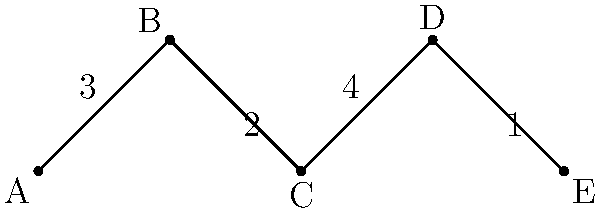At a royal banquet, five distinguished guests (A, B, C, D, and E) are to be seated at a long table. The graph represents the social connections between guests, with edge weights indicating the level of acquaintance (higher numbers mean better acquainted). What is the optimal seating arrangement to maximize social interaction, and what is the total "social score" of this arrangement? To find the optimal seating arrangement, we need to maximize the sum of edge weights between adjacent guests. Let's approach this step-by-step:

1. First, list all possible seating arrangements:
   ABCDE, ABDCE, ABEDC, ACBDE, ACDBE, ACEBD, ADCBE, ADBCE, ADEBC, AEBCD, AECBD, AEDBC

2. For each arrangement, calculate the total "social score" by summing the edge weights between adjacent guests.

3. Let's calculate a few examples:
   ABCDE: 3 + 2 + 4 + 1 = 10
   AEBCD: 1 + 2 + 4 + 3 = 10
   AEDBC: 1 + 4 + 2 + 3 = 10

4. After calculating all arrangements, we find that the maximum score is 10.

5. There are three arrangements that achieve this maximum score:
   ABCDE, AEBCD, and AEDBC

6. Any of these arrangements can be considered optimal, as they all maximize social interaction.

Therefore, one optimal seating arrangement is ABCDE (or EDCBA, as the direction doesn't matter), with a total social score of 10.
Answer: ABCDE (or EDCBA), 10 